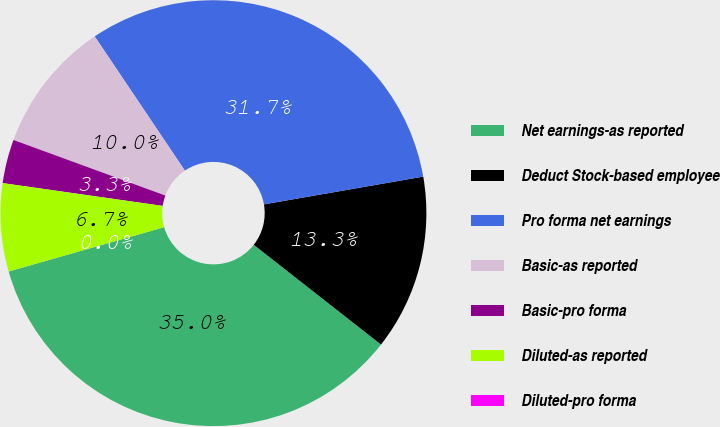Convert chart. <chart><loc_0><loc_0><loc_500><loc_500><pie_chart><fcel>Net earnings-as reported<fcel>Deduct Stock-based employee<fcel>Pro forma net earnings<fcel>Basic-as reported<fcel>Basic-pro forma<fcel>Diluted-as reported<fcel>Diluted-pro forma<nl><fcel>35.0%<fcel>13.33%<fcel>31.67%<fcel>10.0%<fcel>3.33%<fcel>6.67%<fcel>0.0%<nl></chart> 